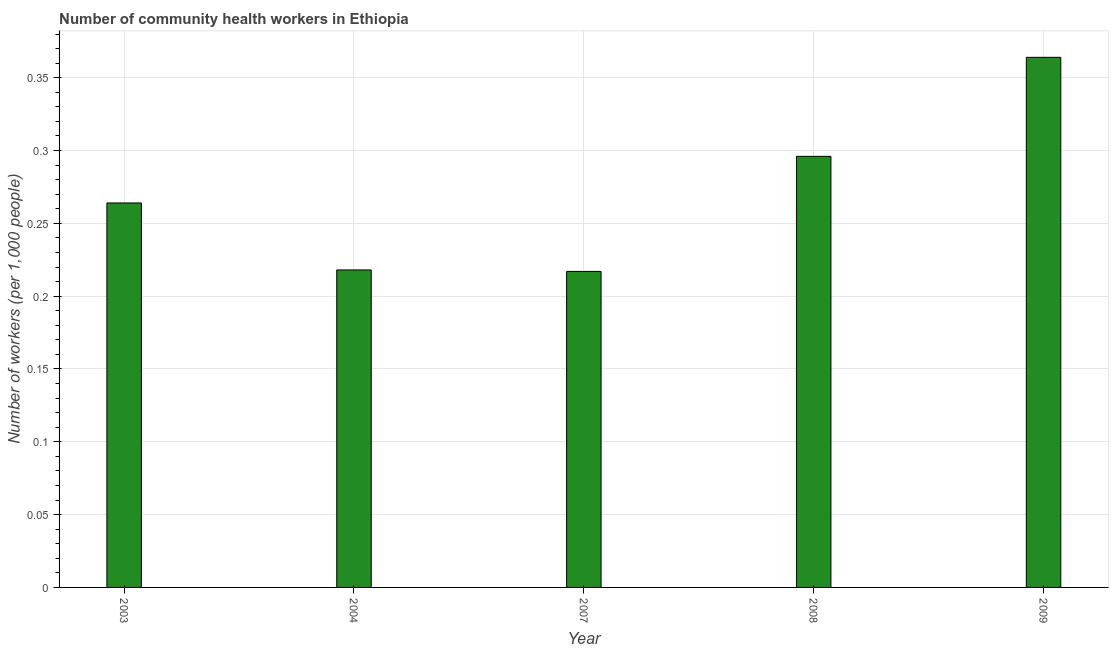Does the graph contain grids?
Offer a terse response. Yes. What is the title of the graph?
Your answer should be very brief. Number of community health workers in Ethiopia. What is the label or title of the Y-axis?
Ensure brevity in your answer.  Number of workers (per 1,0 people). What is the number of community health workers in 2007?
Give a very brief answer. 0.22. Across all years, what is the maximum number of community health workers?
Your answer should be compact. 0.36. Across all years, what is the minimum number of community health workers?
Ensure brevity in your answer.  0.22. In which year was the number of community health workers maximum?
Offer a very short reply. 2009. In which year was the number of community health workers minimum?
Your answer should be very brief. 2007. What is the sum of the number of community health workers?
Provide a succinct answer. 1.36. What is the difference between the number of community health workers in 2003 and 2004?
Your response must be concise. 0.05. What is the average number of community health workers per year?
Provide a succinct answer. 0.27. What is the median number of community health workers?
Ensure brevity in your answer.  0.26. Do a majority of the years between 2003 and 2009 (inclusive) have number of community health workers greater than 0.07 ?
Offer a terse response. Yes. What is the ratio of the number of community health workers in 2004 to that in 2009?
Your answer should be very brief. 0.6. Is the number of community health workers in 2004 less than that in 2009?
Keep it short and to the point. Yes. Is the difference between the number of community health workers in 2007 and 2009 greater than the difference between any two years?
Provide a succinct answer. Yes. What is the difference between the highest and the second highest number of community health workers?
Keep it short and to the point. 0.07. In how many years, is the number of community health workers greater than the average number of community health workers taken over all years?
Offer a terse response. 2. How many years are there in the graph?
Your answer should be very brief. 5. What is the difference between two consecutive major ticks on the Y-axis?
Make the answer very short. 0.05. What is the Number of workers (per 1,000 people) in 2003?
Give a very brief answer. 0.26. What is the Number of workers (per 1,000 people) of 2004?
Provide a succinct answer. 0.22. What is the Number of workers (per 1,000 people) of 2007?
Your response must be concise. 0.22. What is the Number of workers (per 1,000 people) of 2008?
Offer a very short reply. 0.3. What is the Number of workers (per 1,000 people) of 2009?
Your answer should be very brief. 0.36. What is the difference between the Number of workers (per 1,000 people) in 2003 and 2004?
Your answer should be very brief. 0.05. What is the difference between the Number of workers (per 1,000 people) in 2003 and 2007?
Provide a short and direct response. 0.05. What is the difference between the Number of workers (per 1,000 people) in 2003 and 2008?
Keep it short and to the point. -0.03. What is the difference between the Number of workers (per 1,000 people) in 2003 and 2009?
Your response must be concise. -0.1. What is the difference between the Number of workers (per 1,000 people) in 2004 and 2008?
Provide a succinct answer. -0.08. What is the difference between the Number of workers (per 1,000 people) in 2004 and 2009?
Your answer should be compact. -0.15. What is the difference between the Number of workers (per 1,000 people) in 2007 and 2008?
Ensure brevity in your answer.  -0.08. What is the difference between the Number of workers (per 1,000 people) in 2007 and 2009?
Offer a very short reply. -0.15. What is the difference between the Number of workers (per 1,000 people) in 2008 and 2009?
Give a very brief answer. -0.07. What is the ratio of the Number of workers (per 1,000 people) in 2003 to that in 2004?
Offer a very short reply. 1.21. What is the ratio of the Number of workers (per 1,000 people) in 2003 to that in 2007?
Offer a terse response. 1.22. What is the ratio of the Number of workers (per 1,000 people) in 2003 to that in 2008?
Keep it short and to the point. 0.89. What is the ratio of the Number of workers (per 1,000 people) in 2003 to that in 2009?
Your answer should be very brief. 0.72. What is the ratio of the Number of workers (per 1,000 people) in 2004 to that in 2008?
Your answer should be very brief. 0.74. What is the ratio of the Number of workers (per 1,000 people) in 2004 to that in 2009?
Provide a short and direct response. 0.6. What is the ratio of the Number of workers (per 1,000 people) in 2007 to that in 2008?
Offer a very short reply. 0.73. What is the ratio of the Number of workers (per 1,000 people) in 2007 to that in 2009?
Your answer should be compact. 0.6. What is the ratio of the Number of workers (per 1,000 people) in 2008 to that in 2009?
Offer a very short reply. 0.81. 